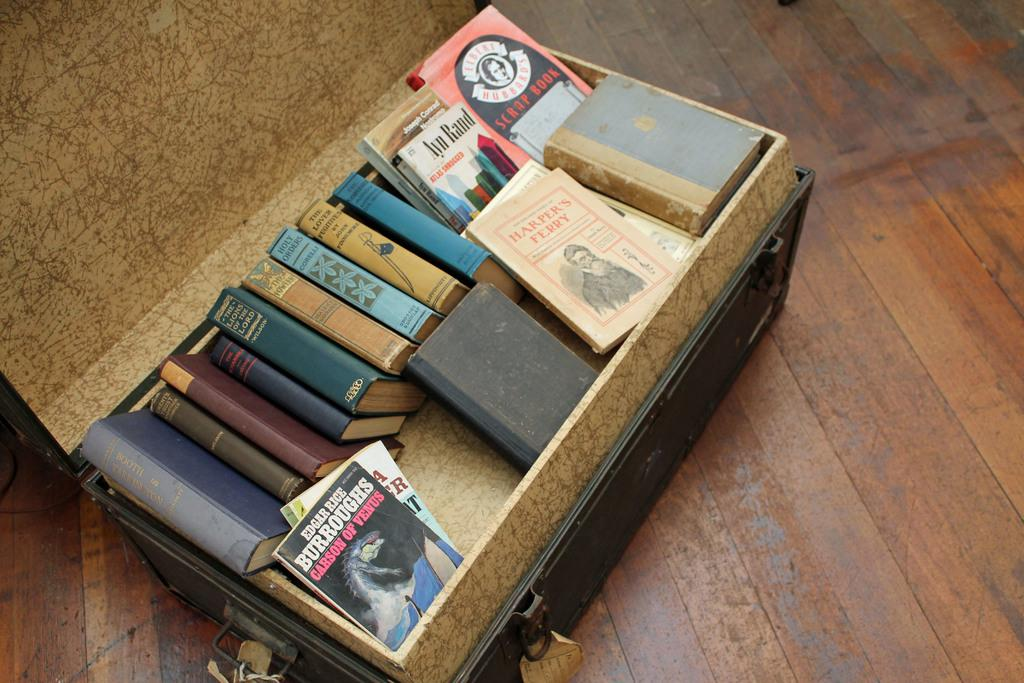<image>
Offer a succinct explanation of the picture presented. A box of books including Atlas Shrugged by Ayn Rand. 